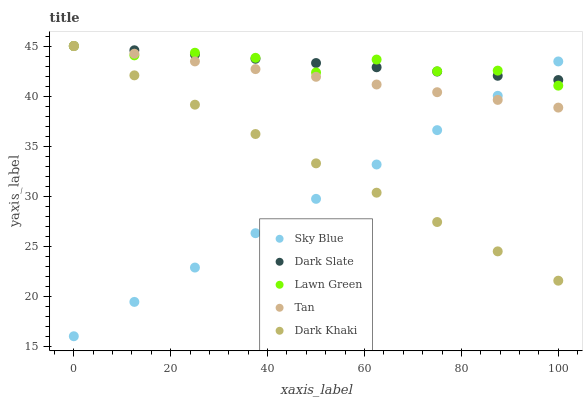Does Sky Blue have the minimum area under the curve?
Answer yes or no. Yes. Does Dark Slate have the maximum area under the curve?
Answer yes or no. Yes. Does Tan have the minimum area under the curve?
Answer yes or no. No. Does Tan have the maximum area under the curve?
Answer yes or no. No. Is Sky Blue the smoothest?
Answer yes or no. Yes. Is Lawn Green the roughest?
Answer yes or no. Yes. Is Tan the smoothest?
Answer yes or no. No. Is Tan the roughest?
Answer yes or no. No. Does Sky Blue have the lowest value?
Answer yes or no. Yes. Does Tan have the lowest value?
Answer yes or no. No. Does Dark Slate have the highest value?
Answer yes or no. Yes. Does Sky Blue have the highest value?
Answer yes or no. No. Does Lawn Green intersect Dark Slate?
Answer yes or no. Yes. Is Lawn Green less than Dark Slate?
Answer yes or no. No. Is Lawn Green greater than Dark Slate?
Answer yes or no. No. 